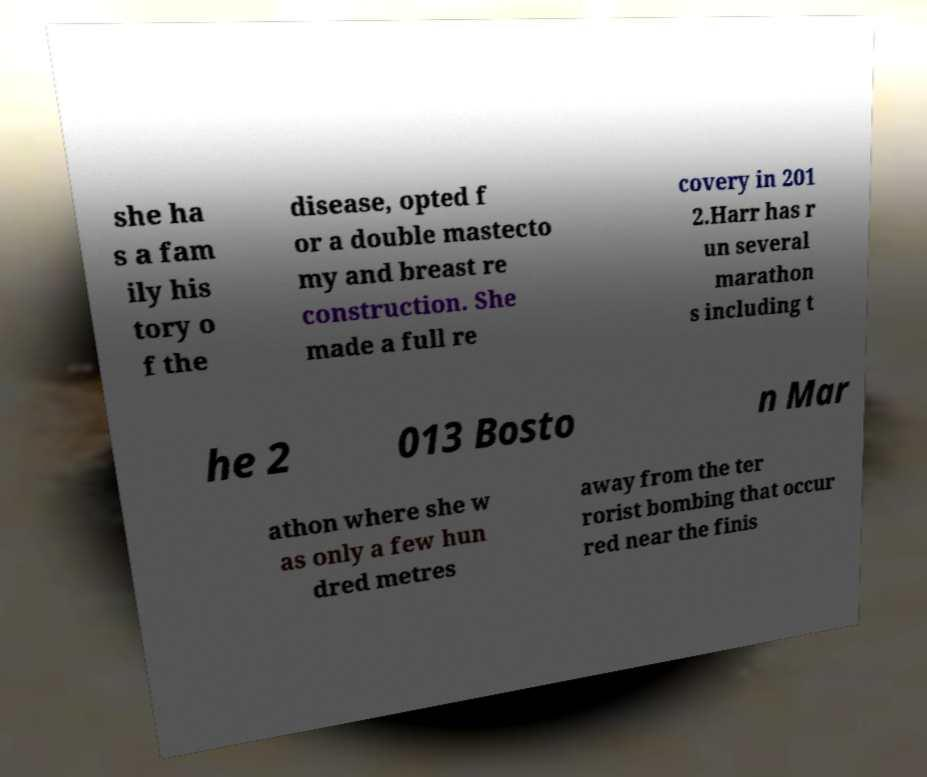I need the written content from this picture converted into text. Can you do that? she ha s a fam ily his tory o f the disease, opted f or a double mastecto my and breast re construction. She made a full re covery in 201 2.Harr has r un several marathon s including t he 2 013 Bosto n Mar athon where she w as only a few hun dred metres away from the ter rorist bombing that occur red near the finis 